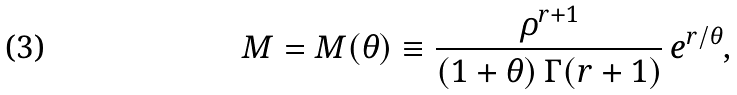Convert formula to latex. <formula><loc_0><loc_0><loc_500><loc_500>M = M ( \theta ) \equiv \frac { \rho ^ { r + 1 } } { ( 1 + \theta ) \, \Gamma ( r + 1 ) } \, e ^ { r / \theta } ,</formula> 